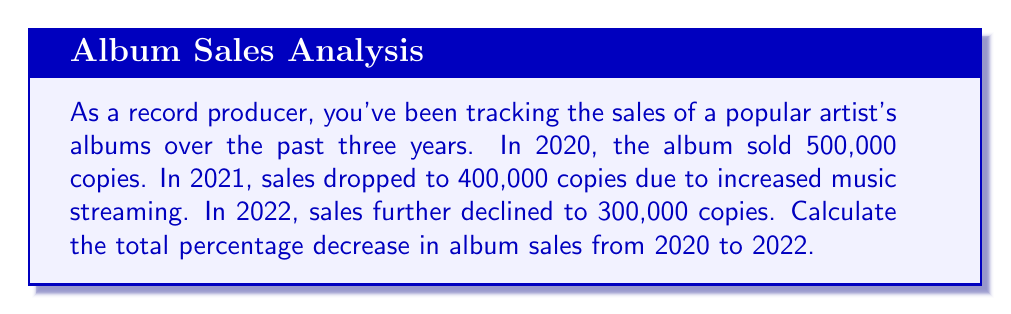Solve this math problem. To solve this problem, we'll follow these steps:

1. Calculate the total change in sales from 2020 to 2022.
2. Express this change as a percentage of the original 2020 sales.

Step 1: Calculate the total change in sales
* 2020 sales: 500,000 copies
* 2022 sales: 300,000 copies
* Change in sales = 300,000 - 500,000 = -200,000 copies

Step 2: Express the change as a percentage
We use the formula:

$$ \text{Percentage change} = \frac{\text{Change in value}}{\text{Original value}} \times 100\% $$

Plugging in our values:

$$ \text{Percentage change} = \frac{-200,000}{500,000} \times 100\% $$

$$ = -0.4 \times 100\% $$

$$ = -40\% $$

The negative sign indicates a decrease in sales.
Answer: The total percentage decrease in album sales from 2020 to 2022 is 40%. 